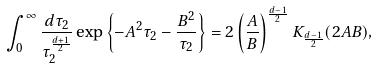<formula> <loc_0><loc_0><loc_500><loc_500>\int _ { 0 } ^ { \infty } \frac { d \tau _ { 2 } } { \tau _ { 2 } ^ { \frac { d + 1 } { 2 } } } \exp \left \{ - A ^ { 2 } \tau _ { 2 } - \frac { B ^ { 2 } } { \tau _ { 2 } } \right \} = 2 \left ( \frac { A } { B } \right ) ^ { \frac { d - 1 } { 2 } } K _ { \frac { d - 1 } { 2 } } ( 2 A B ) ,</formula> 